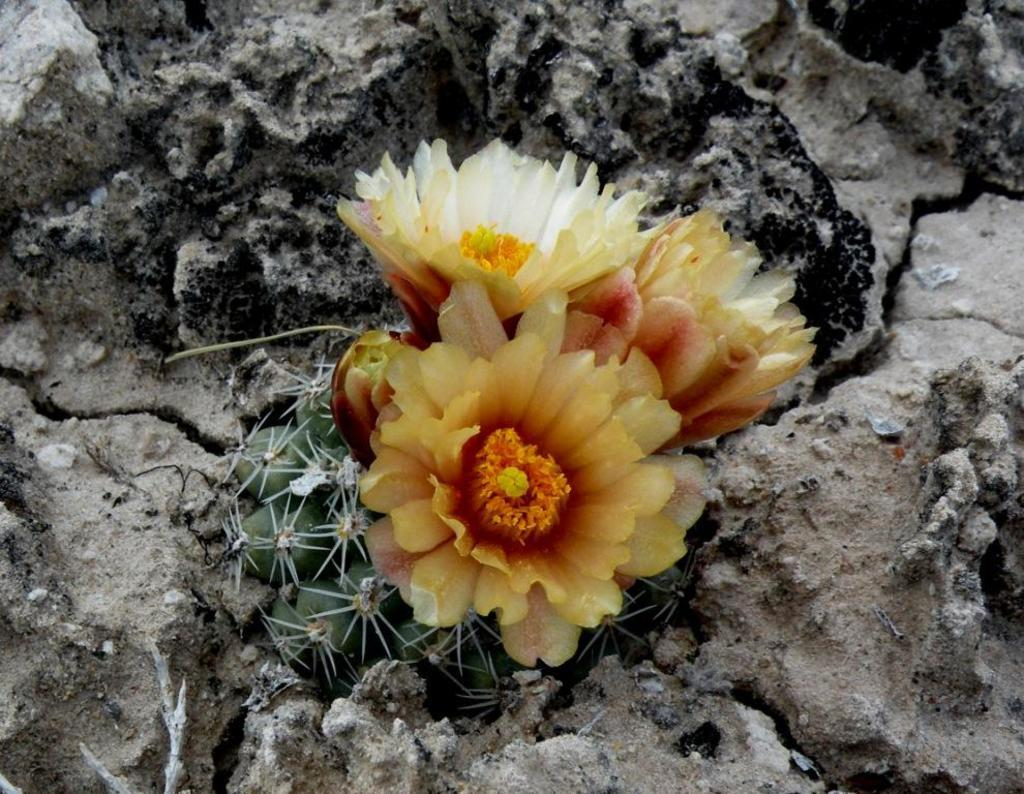What is present in the image? There is a plant in the image. How is the plant positioned in relation to other objects? The plant is between stones. What can be observed about the plant's appearance? The plant contains flowers. How many brothers are visible in the image? There are no brothers present in the image; it features a plant between stones. What type of structure is the plant growing on in the image? The image does not show the plant growing on a specific structure; it is simply positioned between stones. 